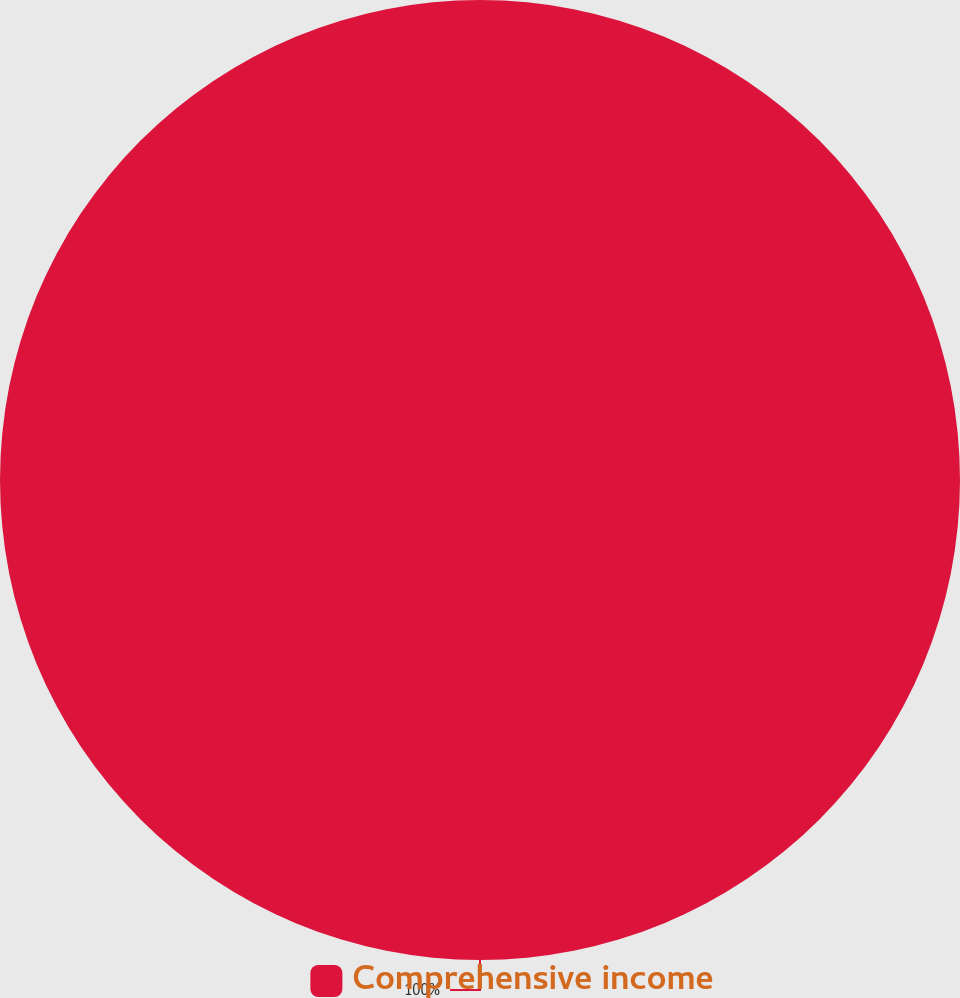<chart> <loc_0><loc_0><loc_500><loc_500><pie_chart><fcel>Comprehensive income<nl><fcel>100.0%<nl></chart> 